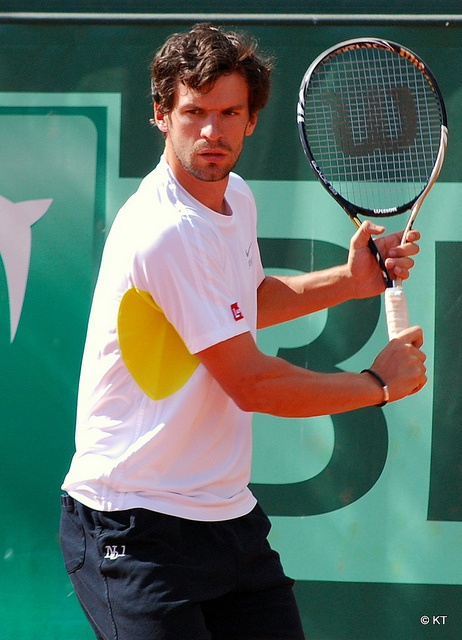Describe the objects in this image and their specific colors. I can see people in black, white, pink, and lightpink tones and tennis racket in black, gray, and teal tones in this image. 